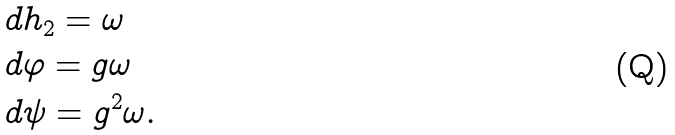Convert formula to latex. <formula><loc_0><loc_0><loc_500><loc_500>& d h _ { 2 } = \omega \\ & d \varphi = g \omega \\ & d \psi = g ^ { 2 } \omega .</formula> 